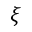<formula> <loc_0><loc_0><loc_500><loc_500>\xi</formula> 